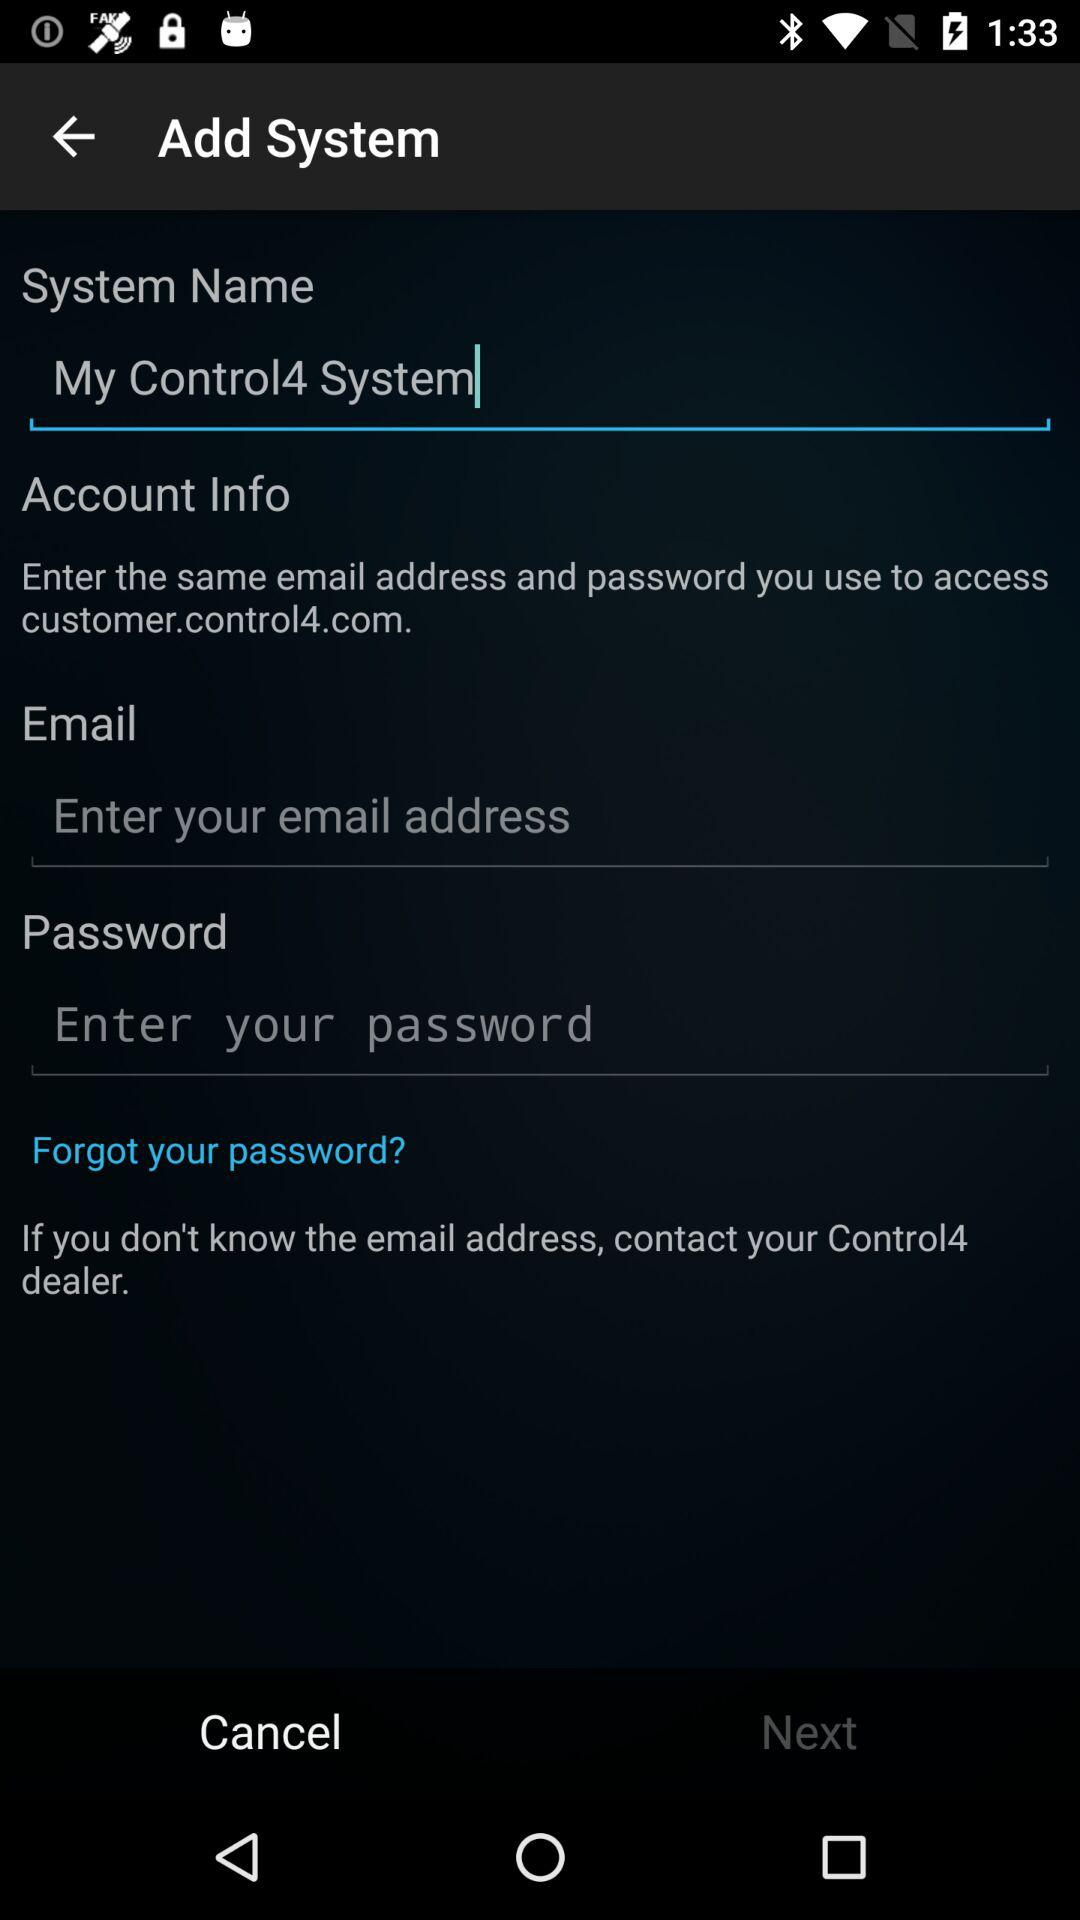What is the name of the system? The name of the system is "My Control4 System". 